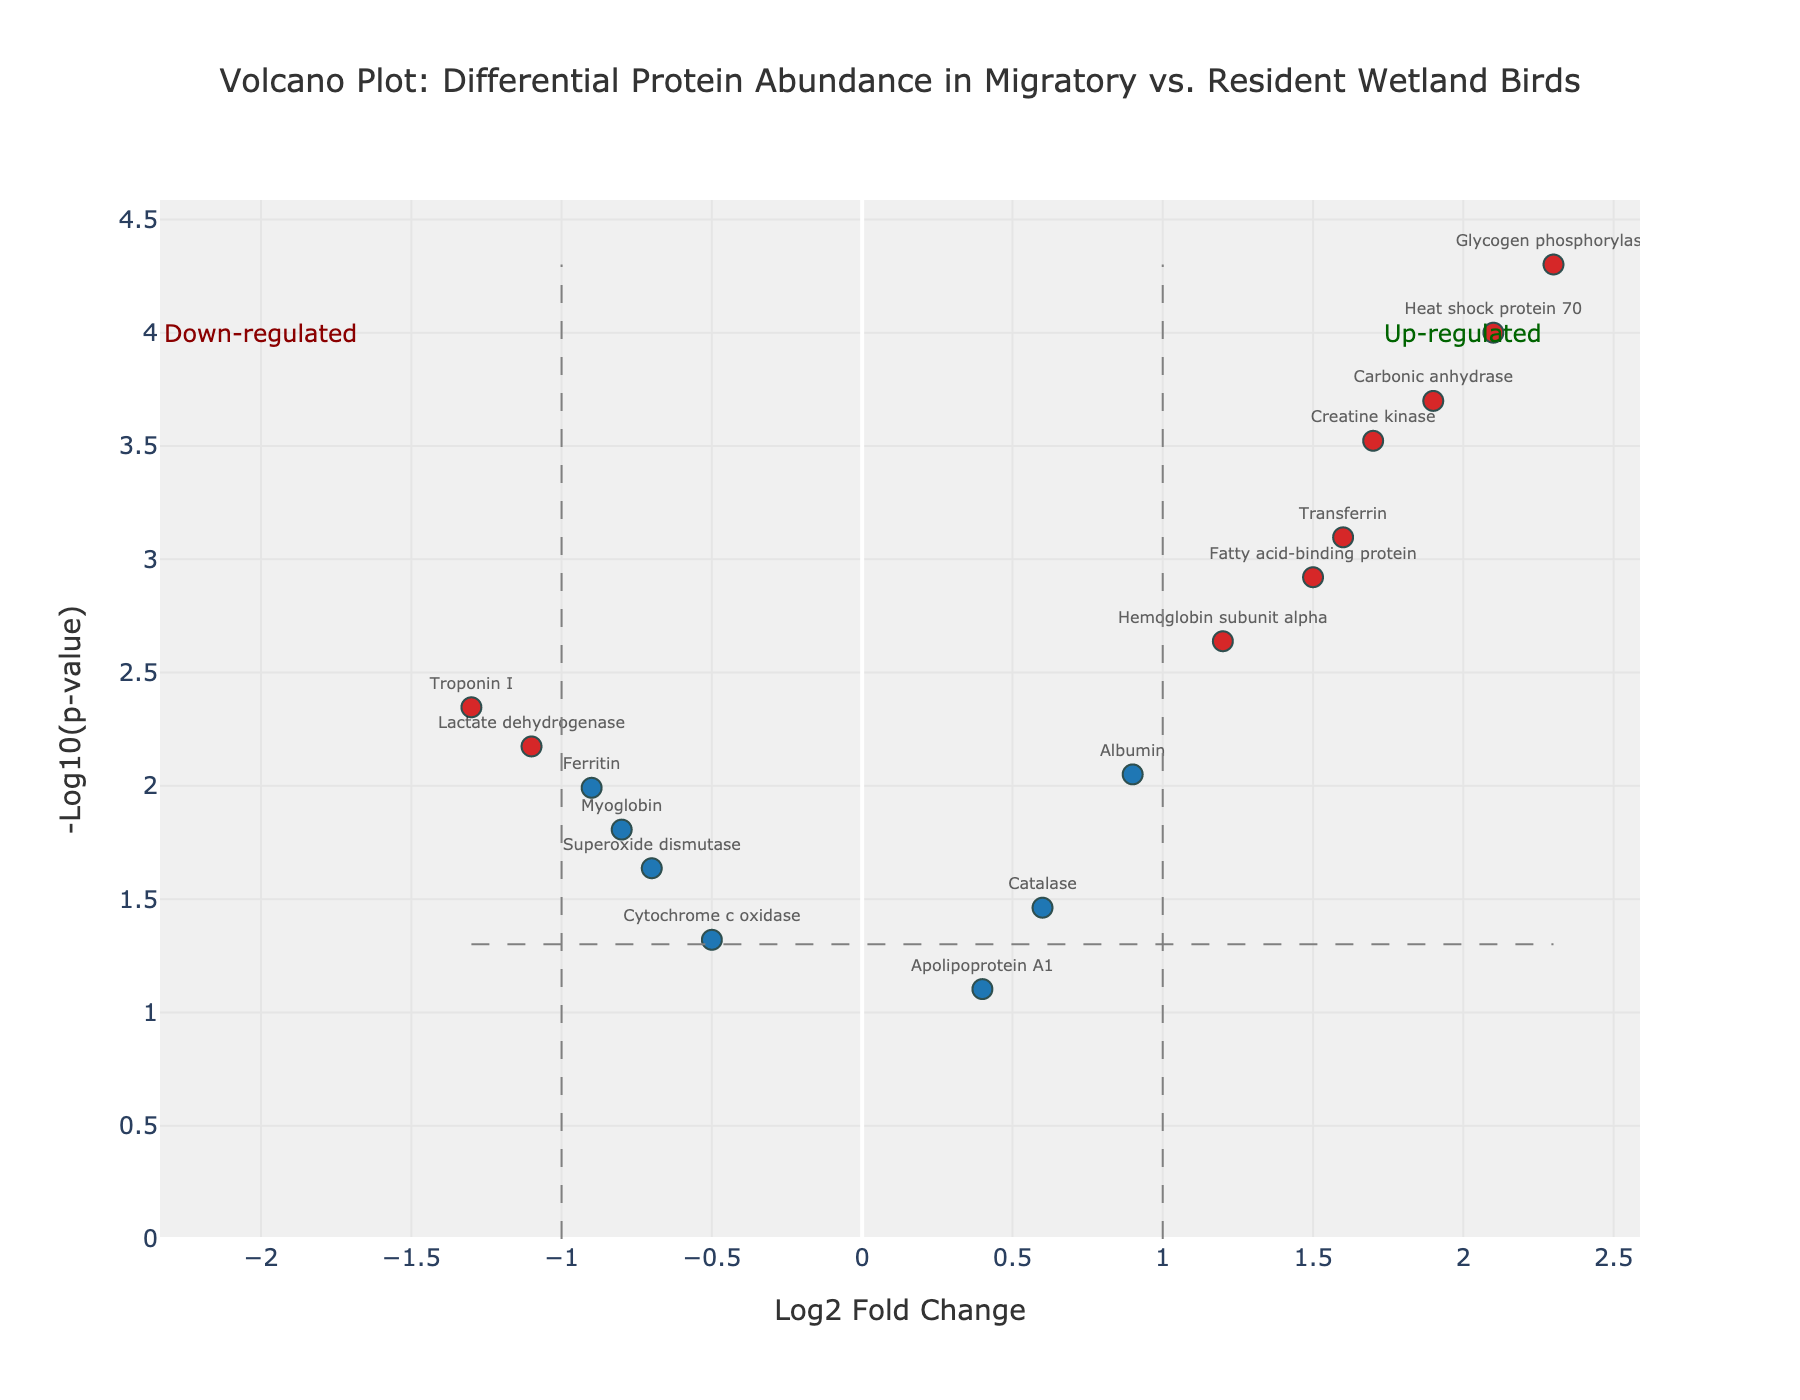What is the title of the plot? The title is usually located at the top of the figure and provides a summary of what the plot is about. For this figure, it shows "Volcano Plot: Differential Protein Abundance in Migratory vs. Resident Wetland Birds".
Answer: Volcano Plot: Differential Protein Abundance in Migratory vs. Resident Wetland Birds Which protein has the highest log2 Fold Change? To determine which protein has the highest log2 Fold Change, look at the x-axis and find the protein label closest to the far right of the plot. Glycogen phosphorylase has the highest log2FC at 2.3.
Answer: Glycogen phosphorylase Which protein has the lowest p-value? The y-axis represents the -log10(p-value), so the highest point in the plot will correspond to the lowest p-value. Heat shock protein 70 is the highest on the y-axis indicating it has the lowest p-value.
Answer: Heat shock protein 70 How many proteins are significantly up-regulated (log2FC > 1 and p-value < 0.05)? Up-regulated proteins will be on the right side of the plot (log2FC > 1), and those with a p-value < 0.05 will be above the horizontal significance threshold line. Counting these points gives Glycogen phosphorylase, Heat shock protein 70, Creatine kinase, Carbonic anhydrase, and Fatty acid-binding protein.
Answer: 5 What's the log2 Fold Change and p-value for Superoxide dismutase? Find the label "Superoxide dismutase" on the plot and note its coordinates: log2 Fold Change (x-axis) and -log10(p-value) (y-axis). Superoxide dismutase has a log2FC of -0.7 and p-value of 0.0231.
Answer: log2FC: -0.7, p-value: 0.0231 Compare the log2 Fold Change of Hemoglobin subunit alpha and Myoglobin. Which has a higher fold change? To compare the fold changes, look at the x-axis coordinates for Hemoglobin subunit alpha (1.2) and Myoglobin (-0.8). Hemoglobin subunit alpha has a higher log2 Fold Change.
Answer: Hemoglobin subunit alpha How many proteins are down-regulated (log2FC < -1 and p-value < 0.05)? Down-regulated proteins will be on the left side of the plot (log2FC < -1), and those with a p-value < 0.05 will be above the horizontal significance line. Only Troponin I and Lactate dehydrogenase meet these criteria.
Answer: 2 